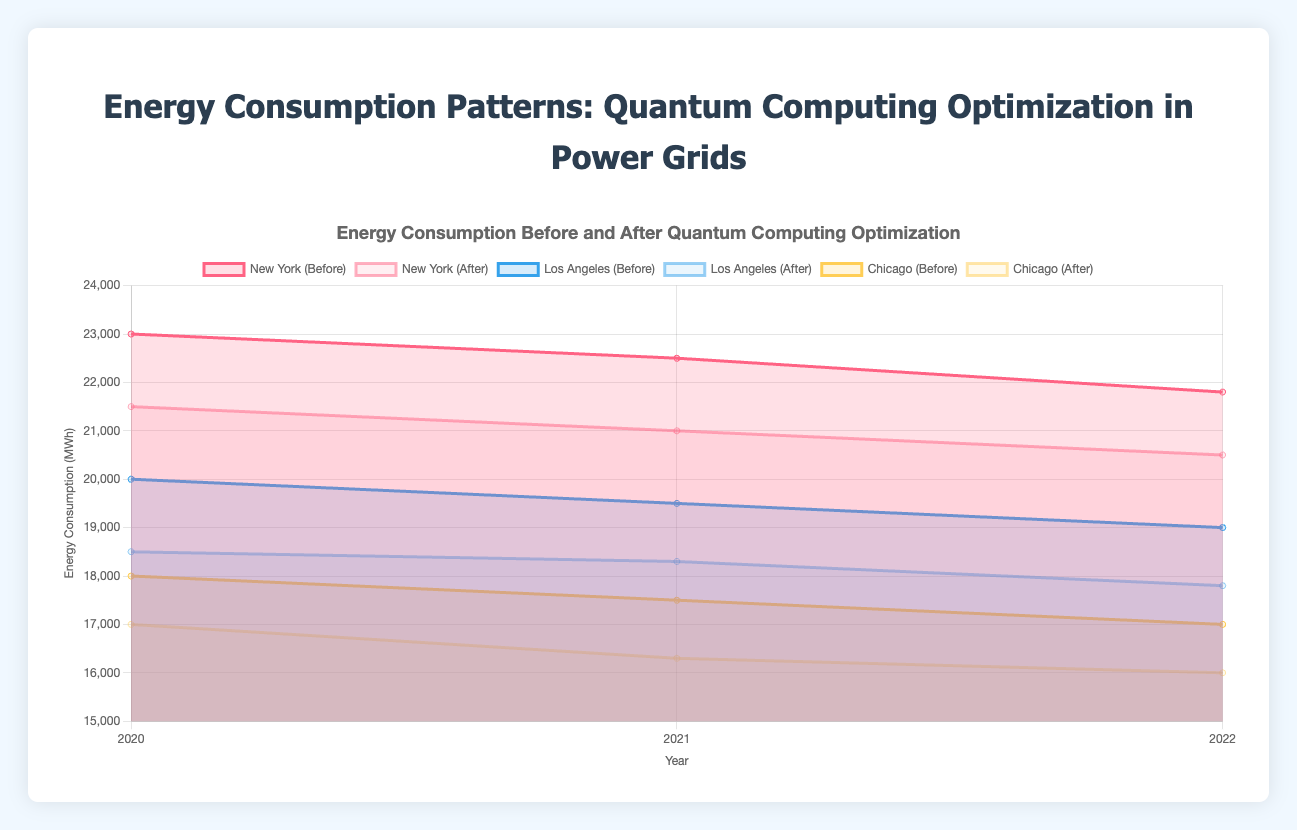What's the title of the chart? The title of the chart is displayed at the top, and it reads "Energy Consumption Before and After Quantum Computing Optimization in Power Grids".
Answer: Energy Consumption Before and After Quantum Computing Optimization in Power Grids What is the lowest recorded energy consumption after optimization for New York? The lowest recorded energy consumption after optimization for New York can be seen by looking at the "New York (After)" dataset line. The lowest point is in 2022 with 20,500 MWh.
Answer: 20,500 MWh Compare the energy consumption before and after optimization in Los Angeles for the year 2021. To compare, look at the "Los Angeles (Before)" and "Los Angeles (After)" lines for the year 2021. The energy consumption before optimization is 19,500 MWh and after optimization is 18,300 MWh. The difference is 1,200 MWh.
Answer: 1,200 MWh Which city shows the greatest reduction in energy consumption from 2020 to 2022 after optimization? Calculate the reduction for each city from 2020 to 2022 after optimization: 
- New York: 21,500 - 20,500 = 1,000 MWh
- Los Angeles: 18,500 - 17,800 = 700 MWh
- Chicago: 17,000 - 16,000 = 1,000 MWh
New York and Chicago both show a reduction of 1,000 MWh, the greatest among the cities.
Answer: New York and Chicago What is the average energy consumption before optimization for Chicago across all years? Sum the values for Chicago before optimization across all years and divide by the number of years: (18,000 + 17,500 + 17,000) / 3 = 17,500 MWh.
Answer: 17,500 MWh Which year recorded the highest energy consumption before optimization for New York? By looking at the New York (Before) dataset line, the highest energy consumption before optimization is in 2020 with 23,000 MWh.
Answer: 23,000 MWh How does the trend of energy consumption after optimization compare between New York and Los Angeles from 2020 to 2022? Examine the lines for "New York (After)" and "Los Angeles (After)". Both show a downward trend in energy consumption from 2020 to 2022. New York goes from 21,500 MWh to 20,500 MWh, and Los Angeles goes from 18,500 MWh to 17,800 MWh.
Answer: Both show a downward trend What is the difference in energy consumption after optimization between the highest and lowest points for Chicago? Identify the highest (2020: 17,000 MWh) and lowest (2022: 16,000 MWh) points in the "Chicago (After)" dataset. The difference is 17,000 - 16,000 = 1,000 MWh.
Answer: 1,000 MWh Is there a consistent pattern in the reduction of energy consumption before and after optimization across all cities? By looking at the datasets for all cities before and after optimization, we can see that in each city (New York, Los Angeles, Chicago) and in each year (2020, 2021, 2022), energy consumption after optimization is consistently lower than before.
Answer: Yes 